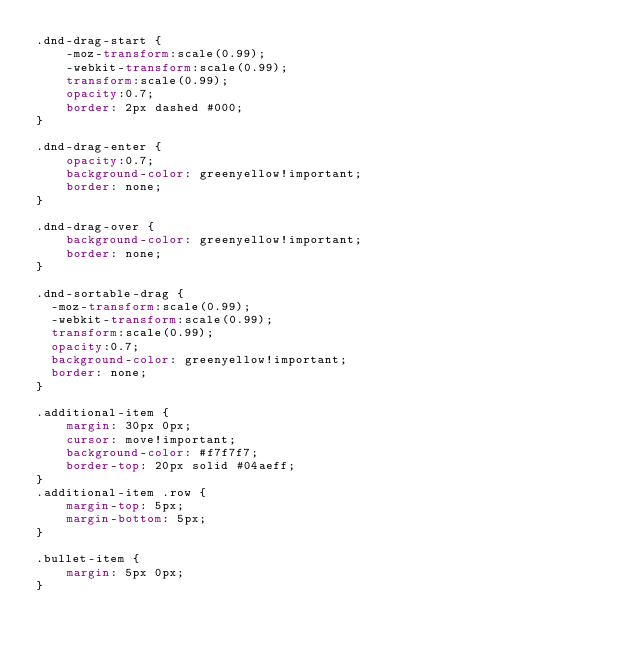Convert code to text. <code><loc_0><loc_0><loc_500><loc_500><_CSS_>.dnd-drag-start {
    -moz-transform:scale(0.99);
    -webkit-transform:scale(0.99);
    transform:scale(0.99);
    opacity:0.7;
    border: 2px dashed #000;
}

.dnd-drag-enter {
    opacity:0.7;
    background-color: greenyellow!important;
    border: none;
}

.dnd-drag-over {
    background-color: greenyellow!important;
    border: none;
}

.dnd-sortable-drag {
  -moz-transform:scale(0.99);
  -webkit-transform:scale(0.99);
  transform:scale(0.99);
  opacity:0.7;
  background-color: greenyellow!important;
  border: none;
}

.additional-item {
    margin: 30px 0px;
    cursor: move!important;
    background-color: #f7f7f7;
    border-top: 20px solid #04aeff;
}
.additional-item .row {
    margin-top: 5px;
    margin-bottom: 5px;
}

.bullet-item {
    margin: 5px 0px;
}</code> 